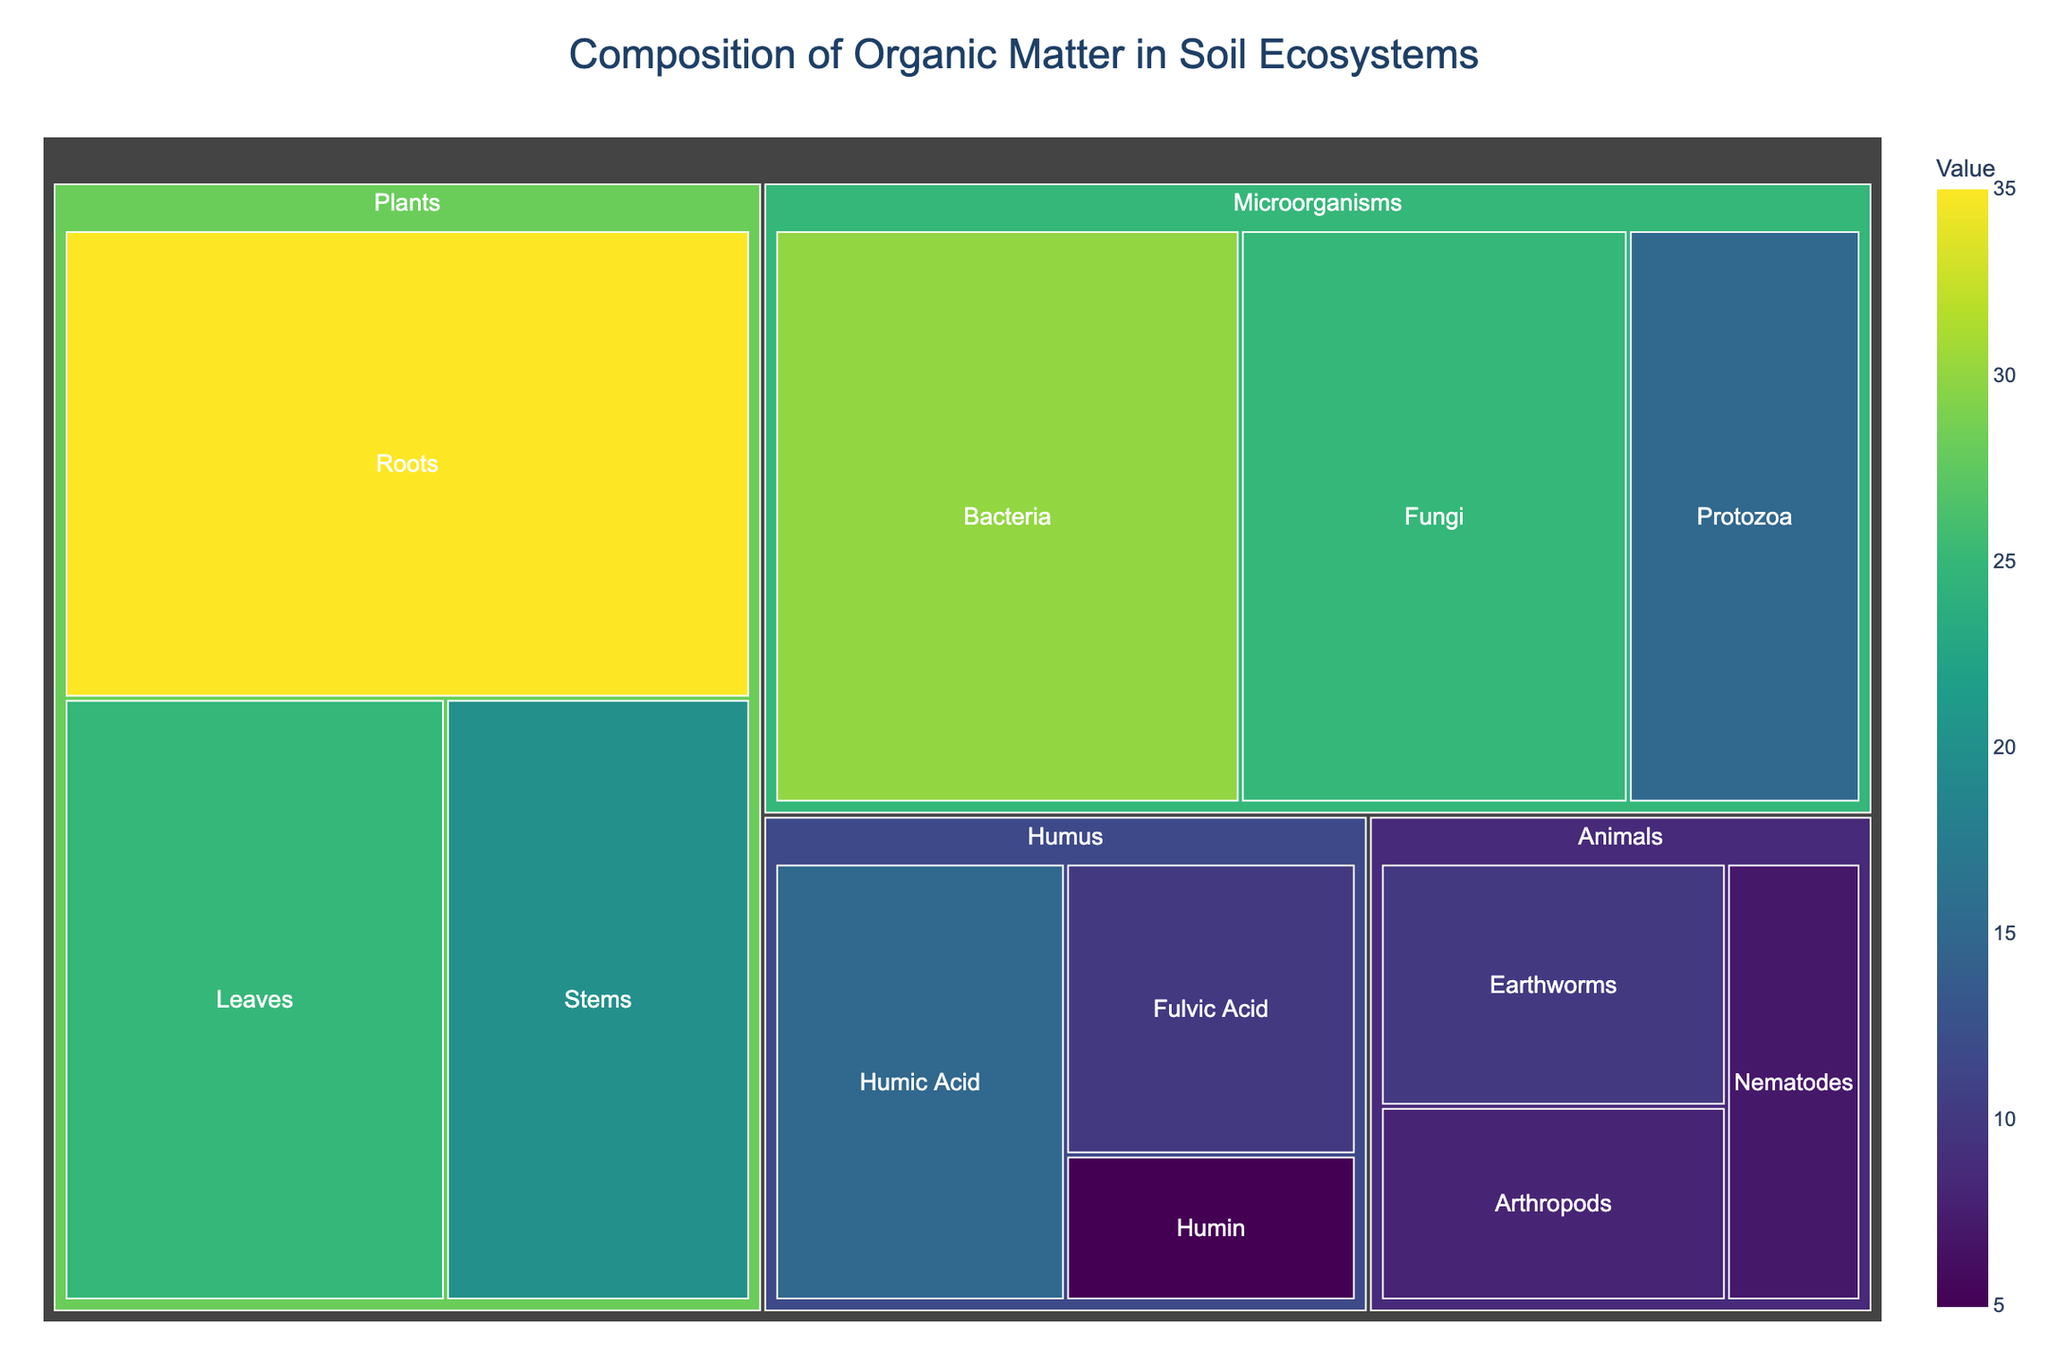What's the title of the figure? The title can be found at the top or in the title section of the figure. It is often meant to summarize what the entire figure is about.
Answer: Composition of Organic Matter in Soil Ecosystems How many subcategories are there in the 'Microorganisms' category? The 'Microorganisms' category includes several subcategories represented as segments on the treemap. Count these segments.
Answer: 3 Which category has the subcategory with the highest value? Check the value associated with each subcategory in the different categories, and identify the highest value and the corresponding category.
Answer: Plants What is the combined value of the subcategories under the 'Humus' category? Sum the values for all subcategories listed under 'Humus'. Calculate 15 (Humic Acid) + 10 (Fulvic Acid) + 5 (Humin) = 30.
Answer: 30 Compare the total value of the 'Animals' category to that of the 'Microorganisms' category. Which one is greater? Sum the values for all subcategories under 'Animals' and 'Microorganisms'. For Animals (10 + 8 + 7 = 25), for Microorganisms (30 + 25 + 15 = 70). Compare these totals.
Answer: Microorganisms Which subcategory within 'Plants' has the lowest value? Compare the values of the subcategories within 'Plants' and identify the smallest one. The values are Roots (35), Leaves (25), and Stems (20).
Answer: Stems What is the difference in value between 'Earthworms' and 'Nematodes'? Find the values for 'Earthworms' and 'Nematodes' under the 'Animals' category and subtract the smaller from the larger. The values are Earthworms (10) and Nematodes (7). Calculate 10 - 7 = 3.
Answer: 3 Within the 'Microorganisms' category, what percentage of the total value is contributed by 'Fungi'? First, find the total value of the 'Microorganisms' subcategories. Then, find the percentage that 'Fungi' contributes to this total value. The total is 30 (Bacteria) + 25 (Fungi) + 15 (Protozoa) = 70. Compute (25 / 70) * 100 ≈ 35.71%.
Answer: 35.71% How does the value of 'Roots' compare to the entire 'Humus' category? Compare the value of the 'Roots' subcategory (35) with the total value of the 'Humus' category (15 + 10 + 5 = 30).
Answer: Roots is greater Is 'Fulvic Acid' or 'Arthropods' contributing more to their respective categories? Compare the values of 'Fulvic Acid' in the 'Humus' category (10) and 'Arthropods' in the 'Animals' category (8).
Answer: Fulvic Acid 